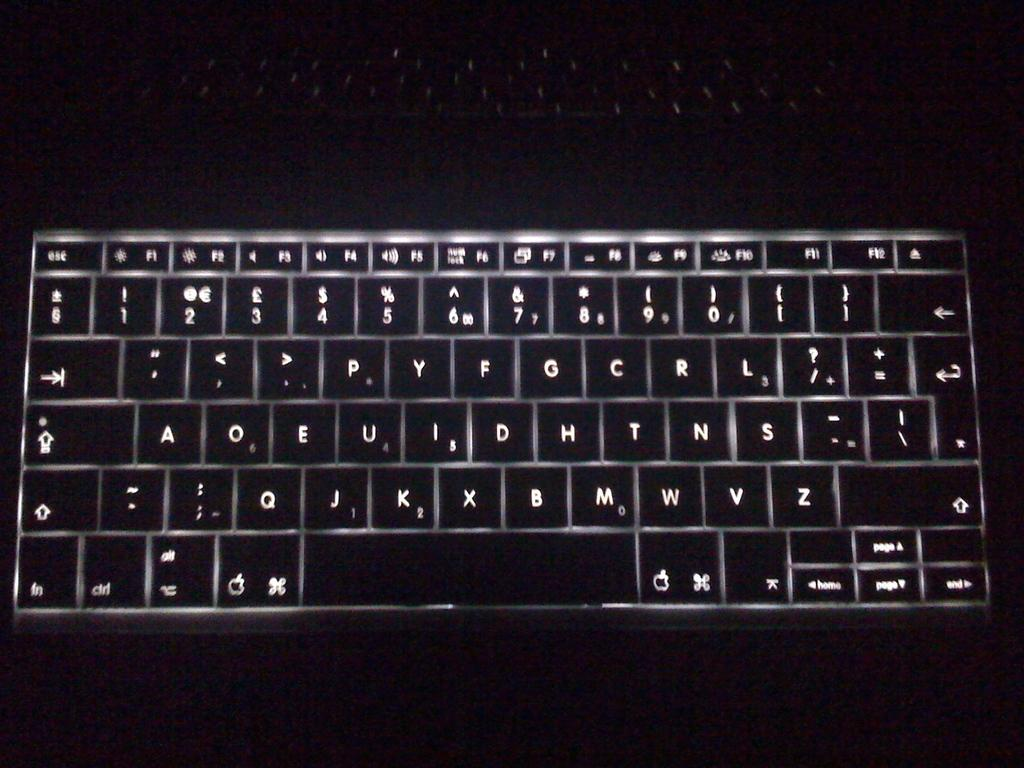<image>
Write a terse but informative summary of the picture. A keyboard that shows numbers and letters A through Z all in the color white. 